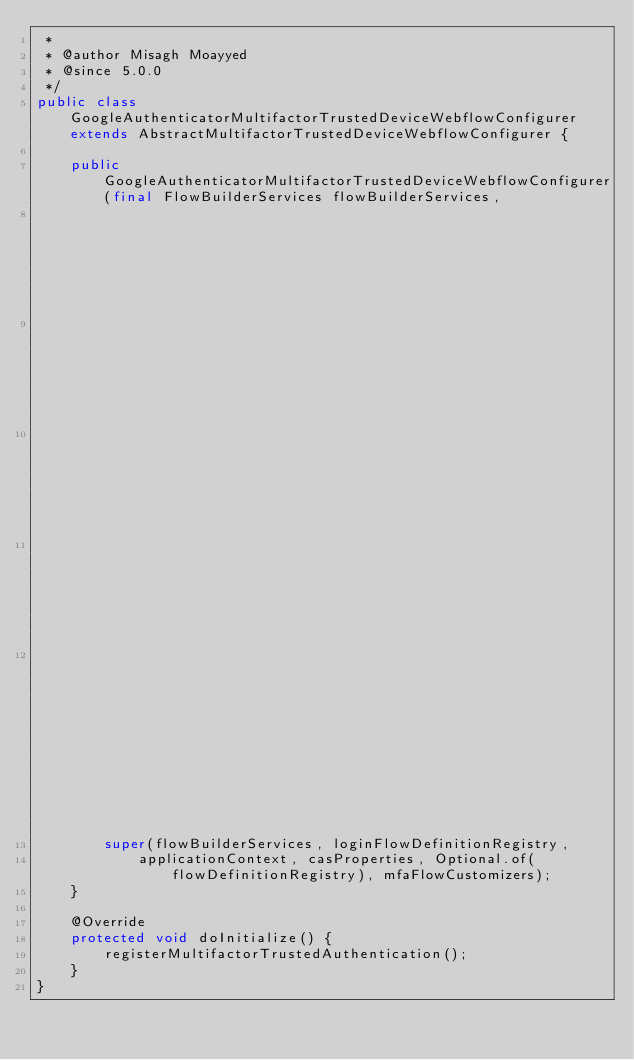<code> <loc_0><loc_0><loc_500><loc_500><_Java_> *
 * @author Misagh Moayyed
 * @since 5.0.0
 */
public class GoogleAuthenticatorMultifactorTrustedDeviceWebflowConfigurer extends AbstractMultifactorTrustedDeviceWebflowConfigurer {

    public GoogleAuthenticatorMultifactorTrustedDeviceWebflowConfigurer(final FlowBuilderServices flowBuilderServices,
                                                                        final FlowDefinitionRegistry loginFlowDefinitionRegistry,
                                                                        final FlowDefinitionRegistry flowDefinitionRegistry,
                                                                        final ConfigurableApplicationContext applicationContext,
                                                                        final CasConfigurationProperties casProperties,
                                                                        final List<CasMultifactorWebflowCustomizer> mfaFlowCustomizers) {
        super(flowBuilderServices, loginFlowDefinitionRegistry,
            applicationContext, casProperties, Optional.of(flowDefinitionRegistry), mfaFlowCustomizers);
    }

    @Override
    protected void doInitialize() {
        registerMultifactorTrustedAuthentication();
    }
}
</code> 